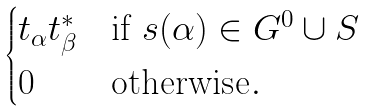Convert formula to latex. <formula><loc_0><loc_0><loc_500><loc_500>\begin{cases} t _ { \alpha } t _ { \beta } ^ { * } & \text {if $s(\alpha) \in G^{0} \cup S$} \\ 0 & \text {otherwise} . \\ \end{cases}</formula> 